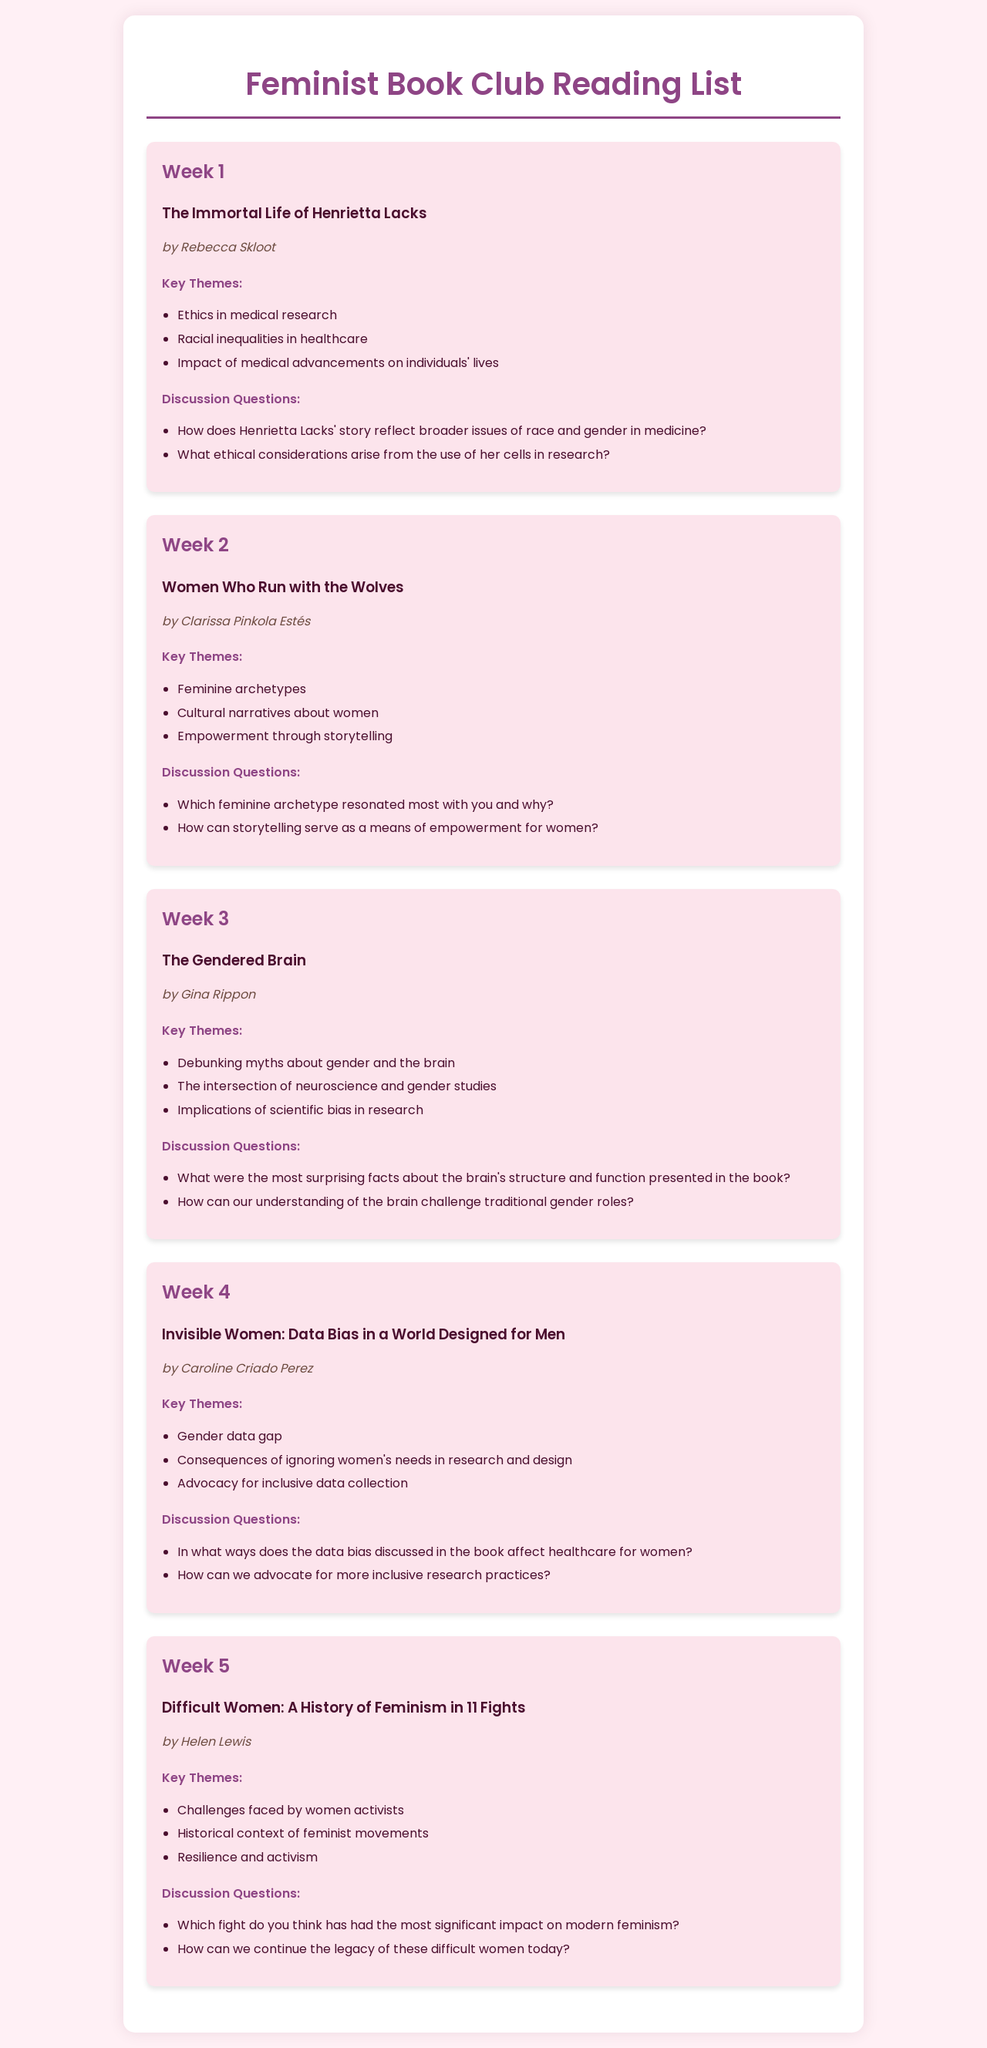What is the title of the book for Week 1? The title of the book for Week 1 is explicitly mentioned under the Week 1 section.
Answer: The Immortal Life of Henrietta Lacks Who is the author of "Invisible Women: Data Bias in a World Designed for Men"? The author's name is listed directly beneath the book title in Week 4.
Answer: Caroline Criado Perez How many weeks are included in the reading list? The document outlines a schedule for the reading list, which is structured into weeks.
Answer: 5 What key theme is discussed in "The Gendered Brain"? The document provides a list of key themes for each book, including specific themes for "The Gendered Brain."
Answer: Debunking myths about gender and the brain Which book discusses feminine archetypes? The title of the book that deals with feminine archetypes can be found under Week 2.
Answer: Women Who Run with the Wolves What discussion question is posed for "Difficult Women"? Discussion questions are specified for each book, including one for "Difficult Women."
Answer: Which fight do you think has had the most significant impact on modern feminism? What is the theme of "Invisible Women" regarding data bias? Each book's key themes include specifics about data bias as discussed in "Invisible Women."
Answer: Gender data gap What color is the background of the reading list document? The background color is mentioned at the beginning of the document, affecting the overall appearance.
Answer: #FFF0F5 